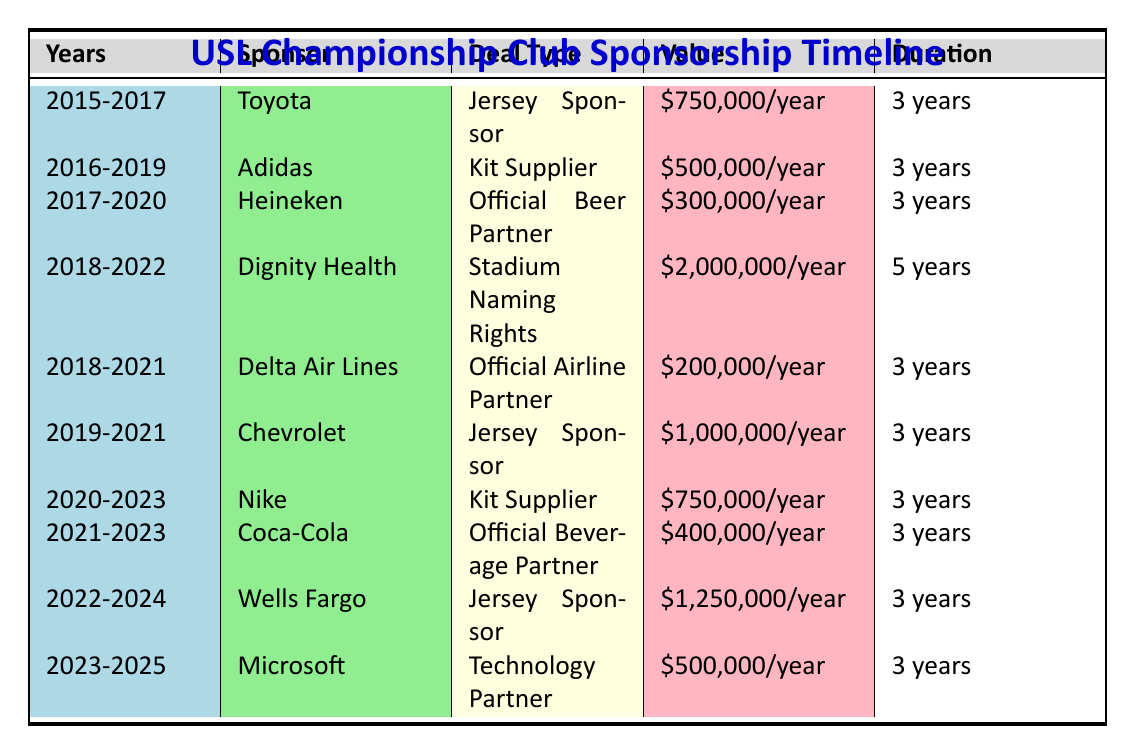What is the value of the sponsorship deal with Dignity Health? The table indicates that Dignity Health has a sponsorship deal valued at $2,000,000 per year for Stadium Naming Rights.
Answer: $2,000,000 per year How long did the sponsorship deal with Toyota last? Looking at the entry for Toyota, the deal lasted from January 1, 2015, to December 31, 2017, totaling 3 years.
Answer: 3 years Which sponsor had the longest duration in the table? The only deal that lasted longer than the others is with Dignity Health, from 2018 to 2022, totaling 5 years. All other deals listed are for 3 years.
Answer: Dignity Health What is the total value of all Jersey Sponsor deals? Calculating the total value: Toyota ($750,000) + Chevrolet ($1,000,000) + Wells Fargo ($1,250,000) = $3,000,000 per year.
Answer: $3,000,000 per year Did the sponsorship value with Nike increase compared to the previous Kit Supplier deal with Adidas? The deal with Nike is valued at $750,000 per year, while the Adidas deal was worth $500,000 per year, showing an increase.
Answer: Yes Which sponsor was associated with both a Jersey Sponsor deal and a Stadium Naming Rights deal? The table shows that Dignity Health had a Stadium Naming Rights deal and Toyota and Chevrolet had Jersey Sponsor deals. However, no single sponsor appears in both categories.
Answer: None How many sponsors were there in total during the year 2021? In 2021, the table lists three active sponsors: Coca-Cola, Nike, and Delta Air Lines.
Answer: 3 sponsors What was the average annual value of all sponsorship deals listed? To find the average, sum the values: ($750,000 + $500,000 + $300,000 + $2,000,000 + $200,000 + $1,000,000 + $750,000 + $400,000 + $1,250,000 + $500,000) = $7,900,000 total, then divide by 10 deals, giving an average of $790,000 per year.
Answer: $790,000 per year Was the sponsorship with Microsoft longer or shorter than that of Coca-Cola? The Microsoft deal lasts from January 1, 2023, to December 31, 2025, which is 3 years, while the Coca-Cola deal spans from January 1, 2021, to December 31, 2023, also 3 years. Thus, they are equal.
Answer: Equal 